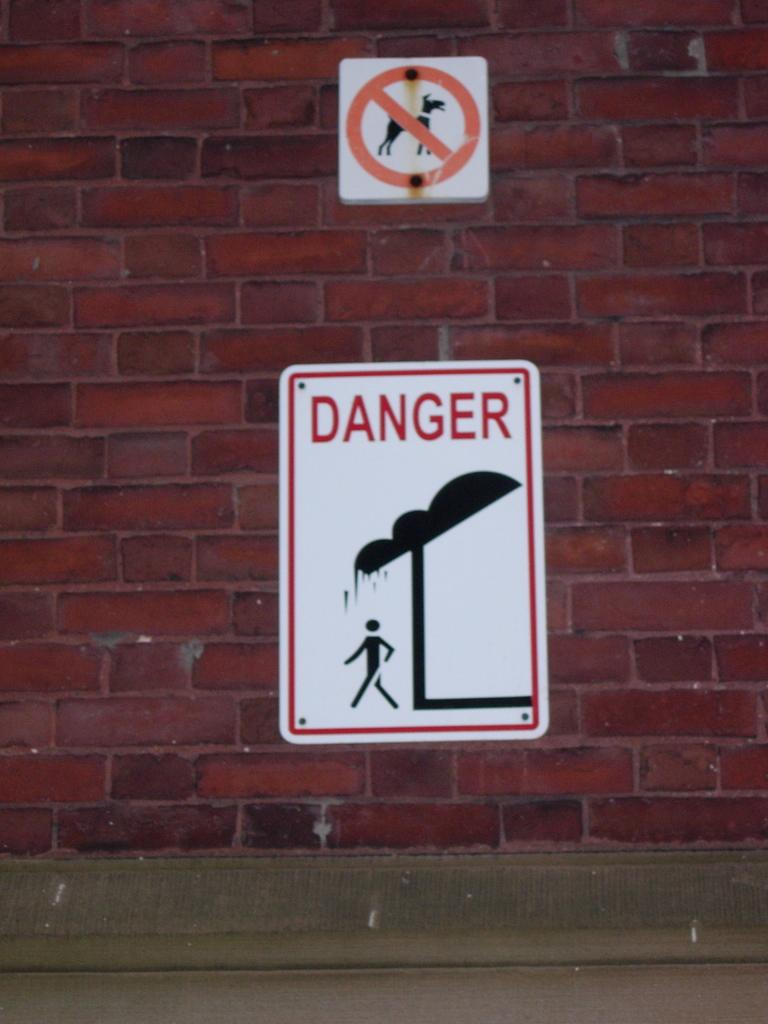<image>
Render a clear and concise summary of the photo. A sign on a wall saying no dogs is above another sign which tells us there is danger of falling water. 